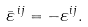<formula> <loc_0><loc_0><loc_500><loc_500>\bar { \varepsilon } ^ { \, i j } = - \varepsilon ^ { i j } .</formula> 